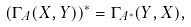<formula> <loc_0><loc_0><loc_500><loc_500>\left ( \Gamma _ { A } ( X , Y ) \right ) ^ { * } = \Gamma _ { A ^ { * } } ( Y , X ) ,</formula> 